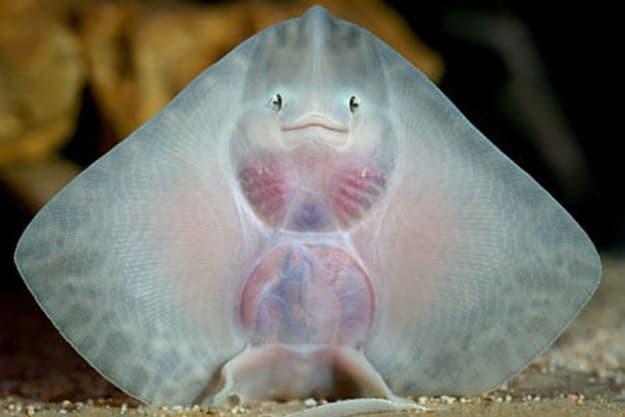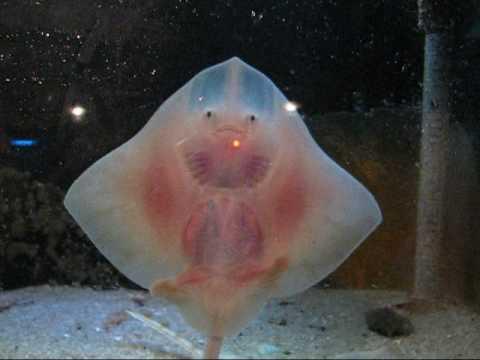The first image is the image on the left, the second image is the image on the right. Analyze the images presented: Is the assertion "All images show an upright stingray with wings extended and underside visible." valid? Answer yes or no. Yes. 